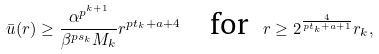<formula> <loc_0><loc_0><loc_500><loc_500>\bar { u } ( r ) \geq \frac { \alpha ^ { p ^ { k + 1 } } } { \beta ^ { p s _ { k } } M _ { k } } r ^ { p t _ { k } + a + 4 } \quad \text {for} \ \ r \geq 2 ^ { \frac { 4 } { p t _ { k } + a + 1 } } r _ { k } ,</formula> 